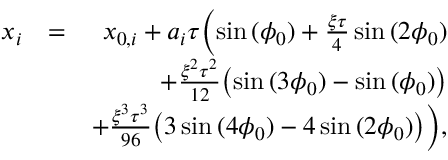<formula> <loc_0><loc_0><loc_500><loc_500>\begin{array} { r l r } { x _ { i } } & { = } & { x _ { 0 , i } + a _ { i } \tau \left ( \sin { ( \phi _ { 0 } ) } + \frac { \xi \tau } { 4 } \sin { ( 2 \phi _ { 0 } ) } } \\ & { + \frac { \xi ^ { 2 } \tau ^ { 2 } } { 1 2 } \left ( \sin { ( 3 \phi _ { 0 } ) } - \sin { ( \phi _ { 0 } ) } \right ) } \\ & { + \frac { \xi ^ { 3 } \tau ^ { 3 } } { 9 6 } \left ( 3 \sin { ( 4 \phi _ { 0 } ) } - 4 \sin { ( 2 \phi _ { 0 } ) } \right ) \right ) , } \end{array}</formula> 